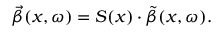Convert formula to latex. <formula><loc_0><loc_0><loc_500><loc_500>\vec { \beta } ( x , \omega ) = S ( x ) \cdot \tilde { \beta } ( x , \omega ) .</formula> 